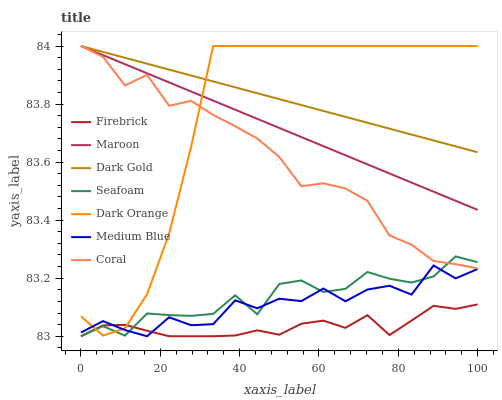Does Firebrick have the minimum area under the curve?
Answer yes or no. Yes. Does Dark Gold have the maximum area under the curve?
Answer yes or no. Yes. Does Dark Gold have the minimum area under the curve?
Answer yes or no. No. Does Firebrick have the maximum area under the curve?
Answer yes or no. No. Is Maroon the smoothest?
Answer yes or no. Yes. Is Medium Blue the roughest?
Answer yes or no. Yes. Is Dark Gold the smoothest?
Answer yes or no. No. Is Dark Gold the roughest?
Answer yes or no. No. Does Firebrick have the lowest value?
Answer yes or no. Yes. Does Dark Gold have the lowest value?
Answer yes or no. No. Does Coral have the highest value?
Answer yes or no. Yes. Does Firebrick have the highest value?
Answer yes or no. No. Is Firebrick less than Maroon?
Answer yes or no. Yes. Is Maroon greater than Seafoam?
Answer yes or no. Yes. Does Dark Orange intersect Seafoam?
Answer yes or no. Yes. Is Dark Orange less than Seafoam?
Answer yes or no. No. Is Dark Orange greater than Seafoam?
Answer yes or no. No. Does Firebrick intersect Maroon?
Answer yes or no. No. 